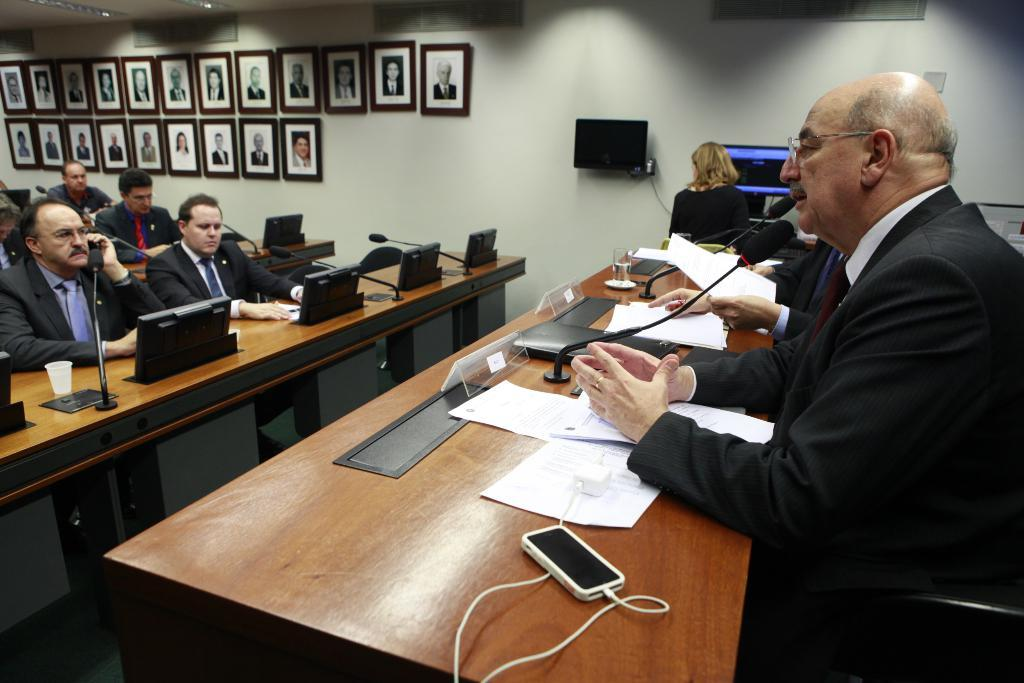What is happening in the image involving the group of people? The people are seated on chairs, and there is a man speaking with the help of a microphone on a table. What can be seen on the wall in the image? There are photo frames on the wall. What type of stamp can be seen on the man's forehead in the image? There is no stamp visible on the man's forehead in the image. How many islands are present in the image? There are no islands present in the image. 